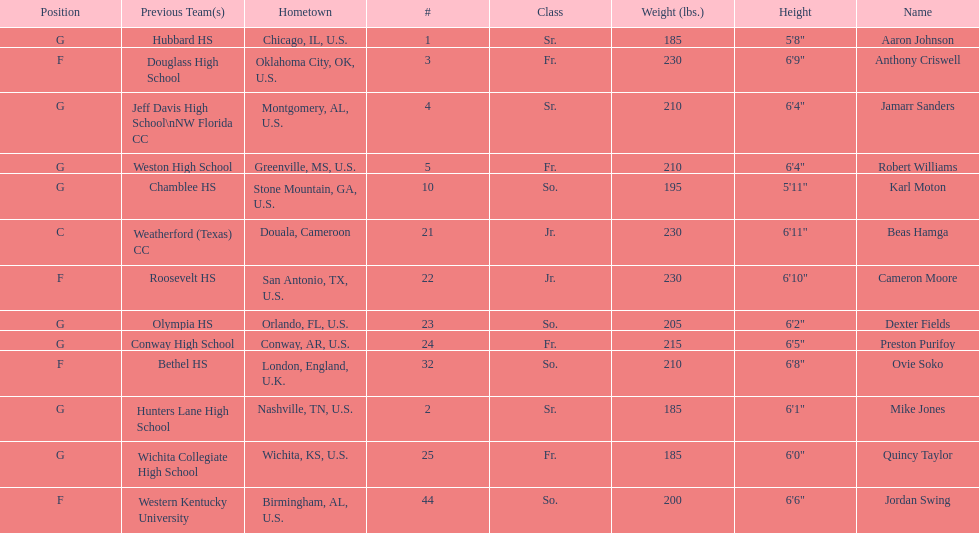What is the difference in weight between dexter fields and quincy taylor? 20. Could you parse the entire table as a dict? {'header': ['Position', 'Previous Team(s)', 'Hometown', '#', 'Class', 'Weight (lbs.)', 'Height', 'Name'], 'rows': [['G', 'Hubbard HS', 'Chicago, IL, U.S.', '1', 'Sr.', '185', '5\'8"', 'Aaron Johnson'], ['F', 'Douglass High School', 'Oklahoma City, OK, U.S.', '3', 'Fr.', '230', '6\'9"', 'Anthony Criswell'], ['G', 'Jeff Davis High School\\nNW Florida CC', 'Montgomery, AL, U.S.', '4', 'Sr.', '210', '6\'4"', 'Jamarr Sanders'], ['G', 'Weston High School', 'Greenville, MS, U.S.', '5', 'Fr.', '210', '6\'4"', 'Robert Williams'], ['G', 'Chamblee HS', 'Stone Mountain, GA, U.S.', '10', 'So.', '195', '5\'11"', 'Karl Moton'], ['C', 'Weatherford (Texas) CC', 'Douala, Cameroon', '21', 'Jr.', '230', '6\'11"', 'Beas Hamga'], ['F', 'Roosevelt HS', 'San Antonio, TX, U.S.', '22', 'Jr.', '230', '6\'10"', 'Cameron Moore'], ['G', 'Olympia HS', 'Orlando, FL, U.S.', '23', 'So.', '205', '6\'2"', 'Dexter Fields'], ['G', 'Conway High School', 'Conway, AR, U.S.', '24', 'Fr.', '215', '6\'5"', 'Preston Purifoy'], ['F', 'Bethel HS', 'London, England, U.K.', '32', 'So.', '210', '6\'8"', 'Ovie Soko'], ['G', 'Hunters Lane High School', 'Nashville, TN, U.S.', '2', 'Sr.', '185', '6\'1"', 'Mike Jones'], ['G', 'Wichita Collegiate High School', 'Wichita, KS, U.S.', '25', 'Fr.', '185', '6\'0"', 'Quincy Taylor'], ['F', 'Western Kentucky University', 'Birmingham, AL, U.S.', '44', 'So.', '200', '6\'6"', 'Jordan Swing']]} 